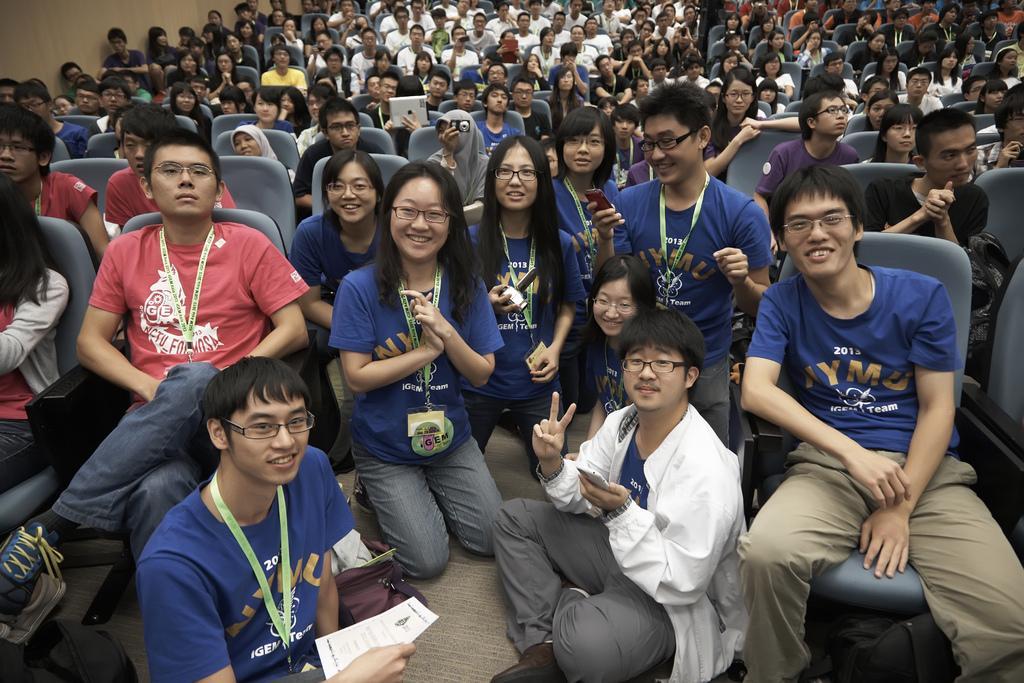In one or two sentences, can you explain what this image depicts? In this picture we can see so many people are sitting on the chairs and few are sitting on the floor. 